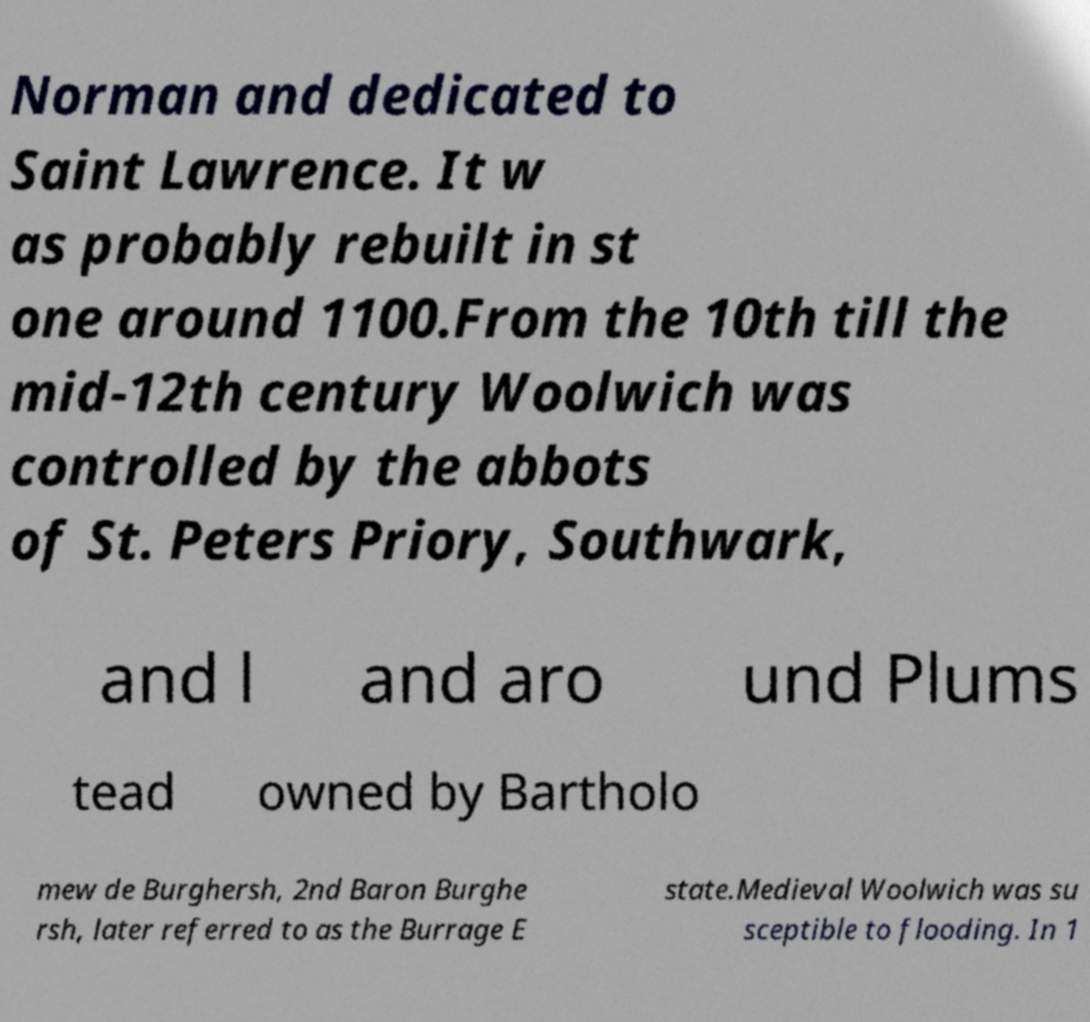There's text embedded in this image that I need extracted. Can you transcribe it verbatim? Norman and dedicated to Saint Lawrence. It w as probably rebuilt in st one around 1100.From the 10th till the mid-12th century Woolwich was controlled by the abbots of St. Peters Priory, Southwark, and l and aro und Plums tead owned by Bartholo mew de Burghersh, 2nd Baron Burghe rsh, later referred to as the Burrage E state.Medieval Woolwich was su sceptible to flooding. In 1 